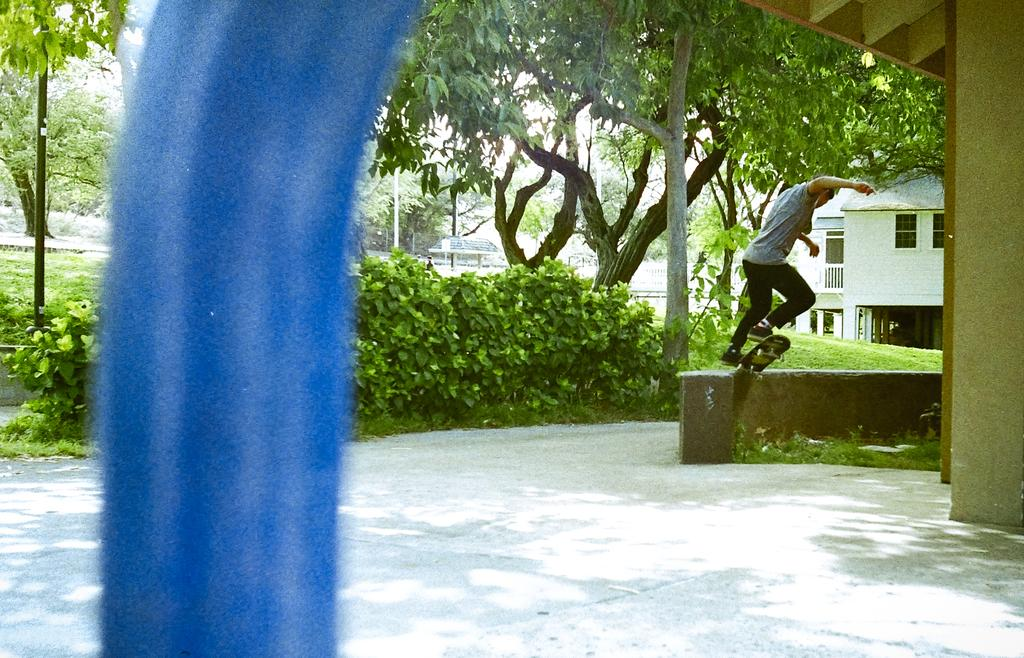What color is the object in the image? The object in the image is blue. What can be seen beneath the person skateboarding in the image? The ground is visible in the image. What activity is the person in the image engaged in? There is a person skateboarding in the image. What type of vegetation can be seen in the image? There are plants and trees in the image. What type of structures are visible in the image? There are buildings in the image. What type of polish is the person applying to their nails in the image? There is no person applying polish to their nails in the image; the main activity is skateboarding. How many people are in the group skateboarding in the image? There is only one person skateboarding in the image, so there is no group. 